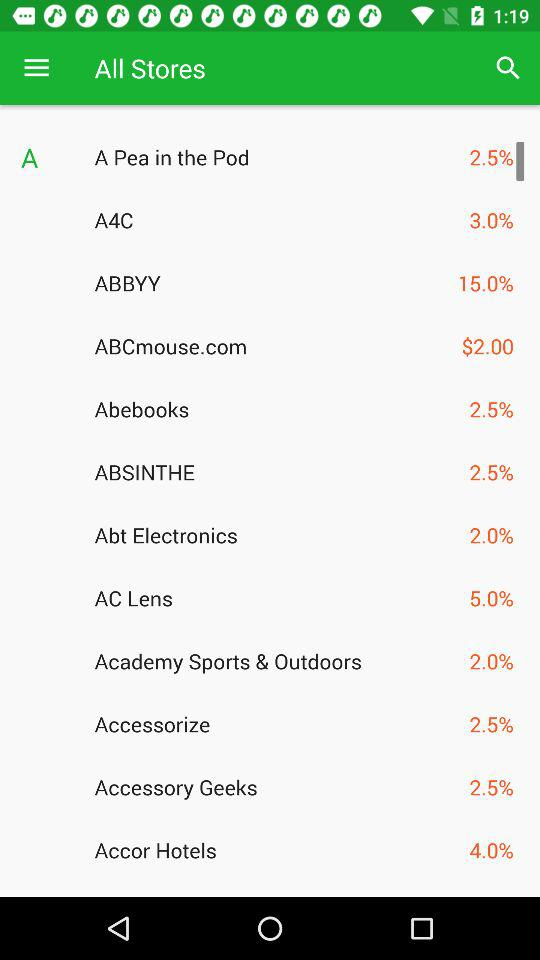For which store is the mentioned percentage 3? The store is A4C. 